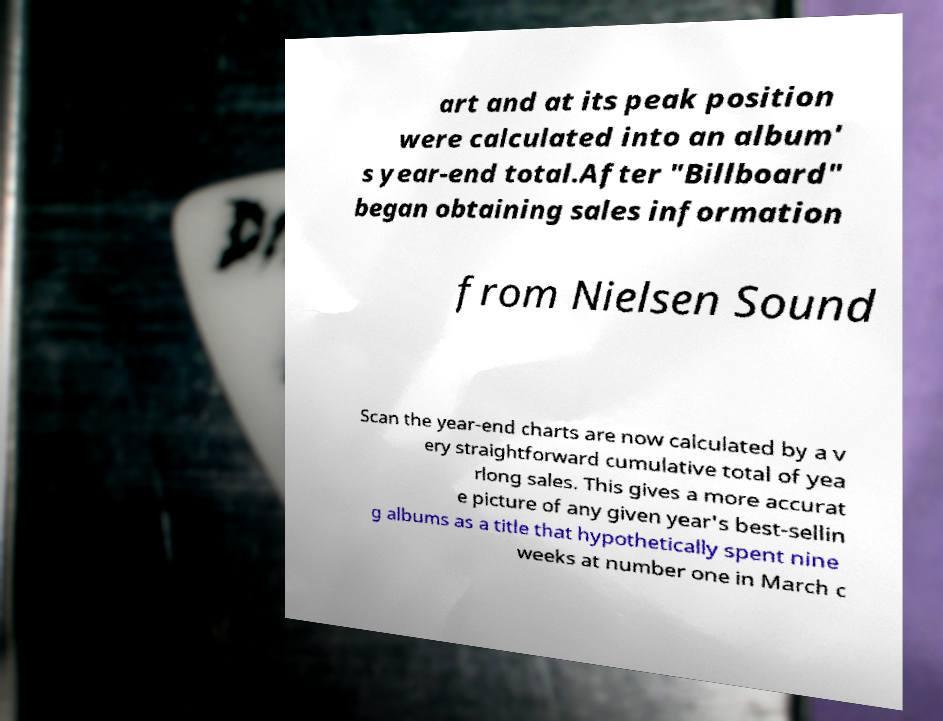What messages or text are displayed in this image? I need them in a readable, typed format. art and at its peak position were calculated into an album' s year-end total.After "Billboard" began obtaining sales information from Nielsen Sound Scan the year-end charts are now calculated by a v ery straightforward cumulative total of yea rlong sales. This gives a more accurat e picture of any given year's best-sellin g albums as a title that hypothetically spent nine weeks at number one in March c 